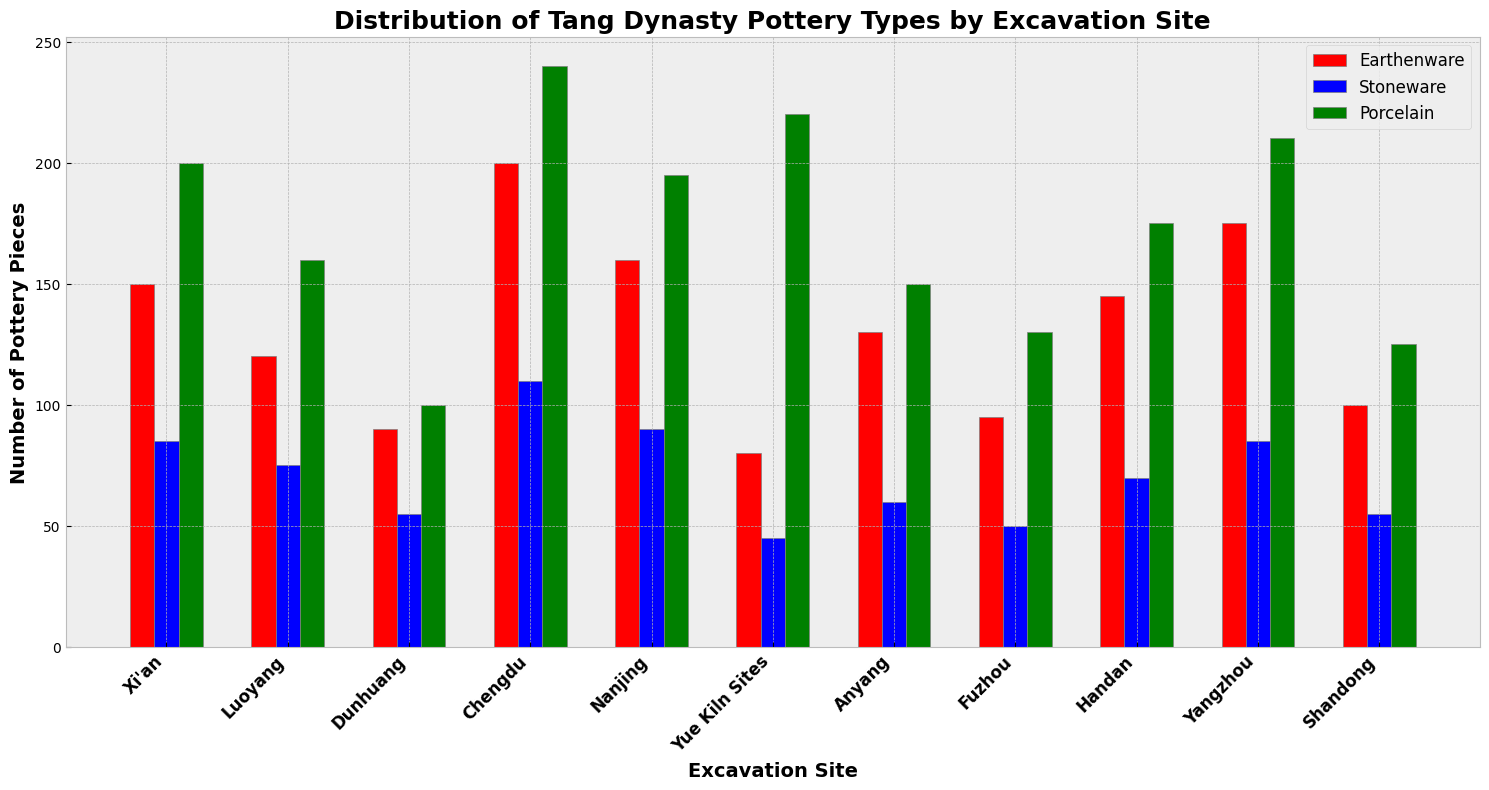Which excavation site has the most porcelain pieces? The height of the green bars represents the number of porcelain pieces. The tallest green bar is in Chengdu.
Answer: Chengdu Which excavation site has the least stoneware pieces? The height of the blue bars represents the number of stoneware pieces. The shortest blue bar is in Yue Kiln Sites.
Answer: Yue Kiln Sites How many more earthenware pieces are there in Xi'an compared to Anyang? The red bar for Earthenware in Xi'an is 150, and in Anyang, it is 130. Subtract 130 from 150.
Answer: 20 What is the total number of pottery pieces found in Nanjing? Add the values of the red, blue, and green bars for Nanjing: 160 (Earthenware) + 90 (Stoneware) + 195 (Porcelain).
Answer: 445 Which two excavation sites have an equal number of stoneware pieces, and how many? The blue bars for stoneware in Xi'an and Yangzhou are equal, both have 85.
Answer: Xi'an and Yangzhou, 85 What is the difference in the number of porcelain pieces between Chengdu and Dunhuang? The green bar for porcelain in Chengdu is 240, and in Dunhuang, it is 100. Subtract 100 from 240.
Answer: 140 Which type of pottery is the least common in Yue Kiln Sites? The shortest bar in Yue Kiln Sites is the blue bar, which represents stoneware.
Answer: Stoneware How many pottery pieces of each type were found in Luoyang? Refer to the heights of the red, blue, and green bars for Luoyang: Earthenware: 120, Stoneware: 75, Porcelain: 160.
Answer: Earthenware: 120, Stoneware: 75, Porcelain: 160 Which site has the second highest amount of earthenware? The second tallest red bar, after Chengdu, is in Yangzhou.
Answer: Yangzhou How much higher is the porcelain count in Yue Kiln Sites compared to the earthenware count in the same site? The green bar for porcelain in Yue Kiln Sites is 220, and the red bar for earthenware is 80. Subtract 80 from 220.
Answer: 140 